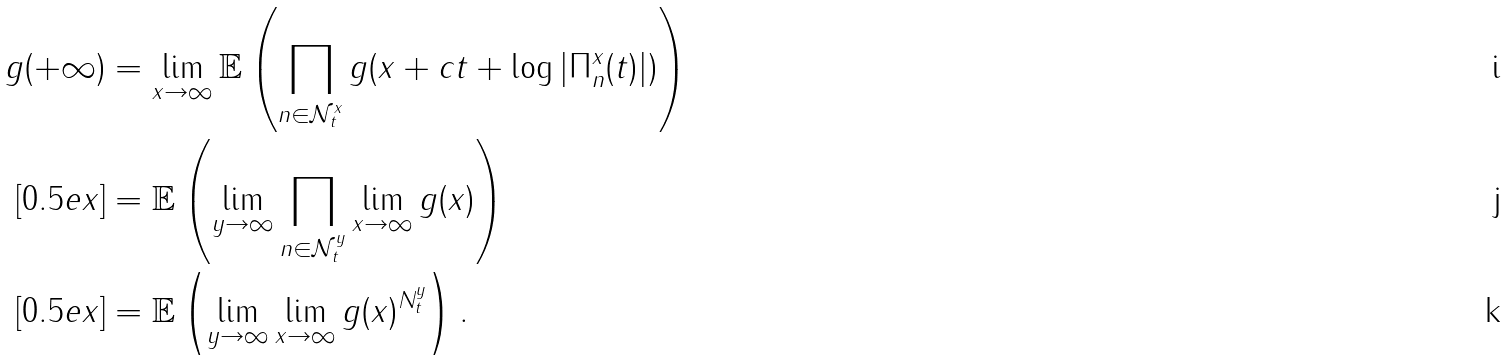Convert formula to latex. <formula><loc_0><loc_0><loc_500><loc_500>g ( + \infty ) & = \lim _ { x \to \infty } \mathbb { E } \left ( \prod _ { n \in \mathcal { N } ^ { x } _ { t } } g ( x + c t + \log | \Pi ^ { x } _ { n } ( t ) | ) \right ) \\ [ 0 . 5 e x ] & = \mathbb { E } \left ( \lim _ { y \to \infty } \prod _ { n \in \mathcal { N } ^ { y } _ { t } } \lim _ { x \to \infty } g ( x ) \right ) \\ [ 0 . 5 e x ] & = \mathbb { E } \left ( \lim _ { y \to \infty } \lim _ { x \to \infty } g ( x ) ^ { N ^ { y } _ { t } } \right ) .</formula> 